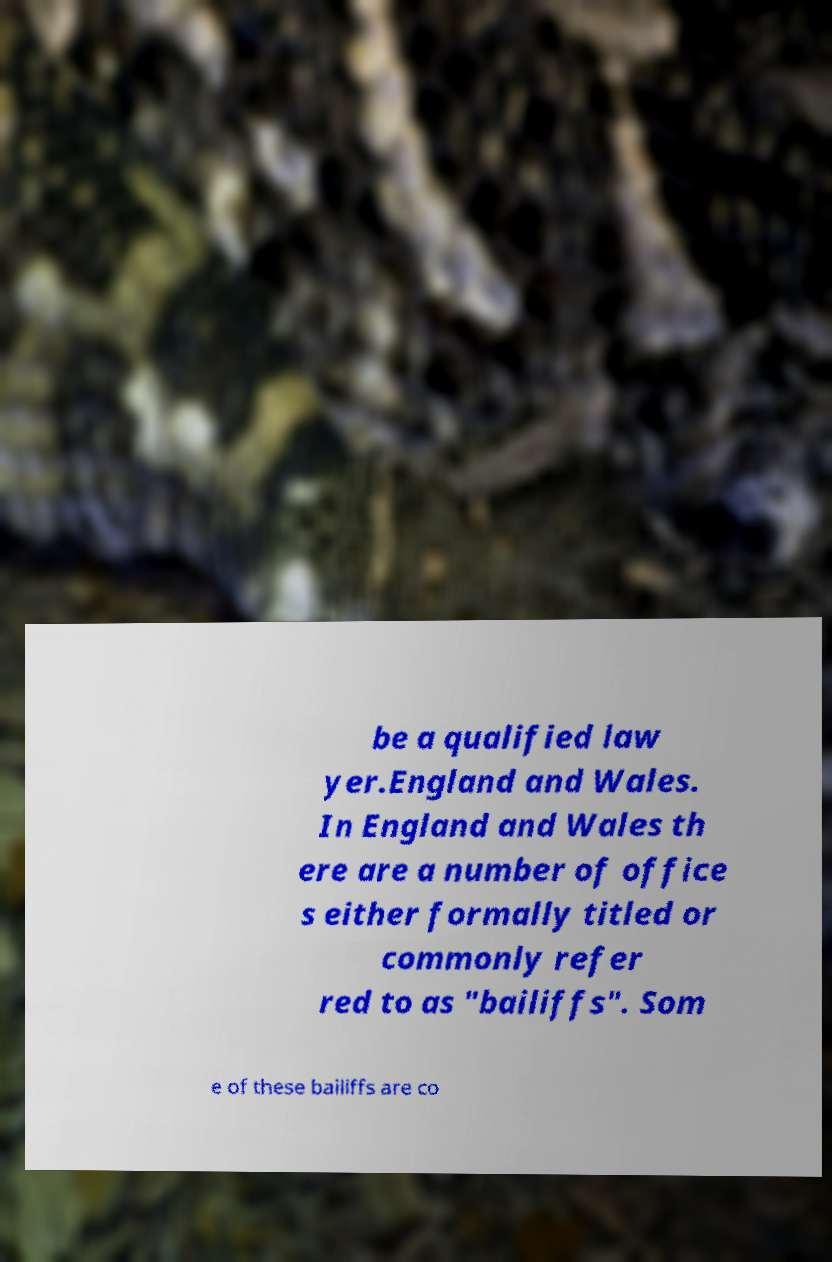Can you accurately transcribe the text from the provided image for me? be a qualified law yer.England and Wales. In England and Wales th ere are a number of office s either formally titled or commonly refer red to as "bailiffs". Som e of these bailiffs are co 